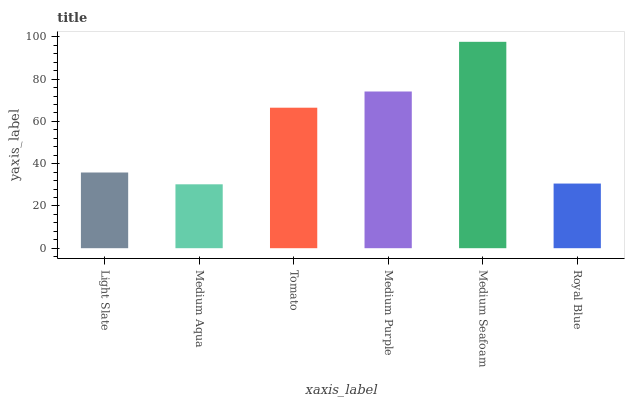Is Medium Aqua the minimum?
Answer yes or no. Yes. Is Medium Seafoam the maximum?
Answer yes or no. Yes. Is Tomato the minimum?
Answer yes or no. No. Is Tomato the maximum?
Answer yes or no. No. Is Tomato greater than Medium Aqua?
Answer yes or no. Yes. Is Medium Aqua less than Tomato?
Answer yes or no. Yes. Is Medium Aqua greater than Tomato?
Answer yes or no. No. Is Tomato less than Medium Aqua?
Answer yes or no. No. Is Tomato the high median?
Answer yes or no. Yes. Is Light Slate the low median?
Answer yes or no. Yes. Is Medium Seafoam the high median?
Answer yes or no. No. Is Tomato the low median?
Answer yes or no. No. 